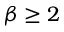<formula> <loc_0><loc_0><loc_500><loc_500>\beta \geq 2</formula> 